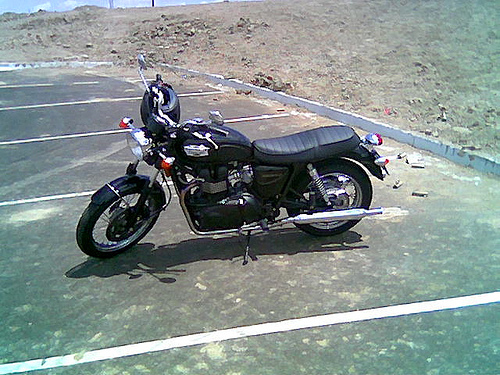<image>What brand of bike is this bike? I am not sure about the brand of the bike. It could be Harley Davidson or Honda. What brand of bike is this bike? I don't know the brand of this bike. It can be either Harley Davidson or Honda. 